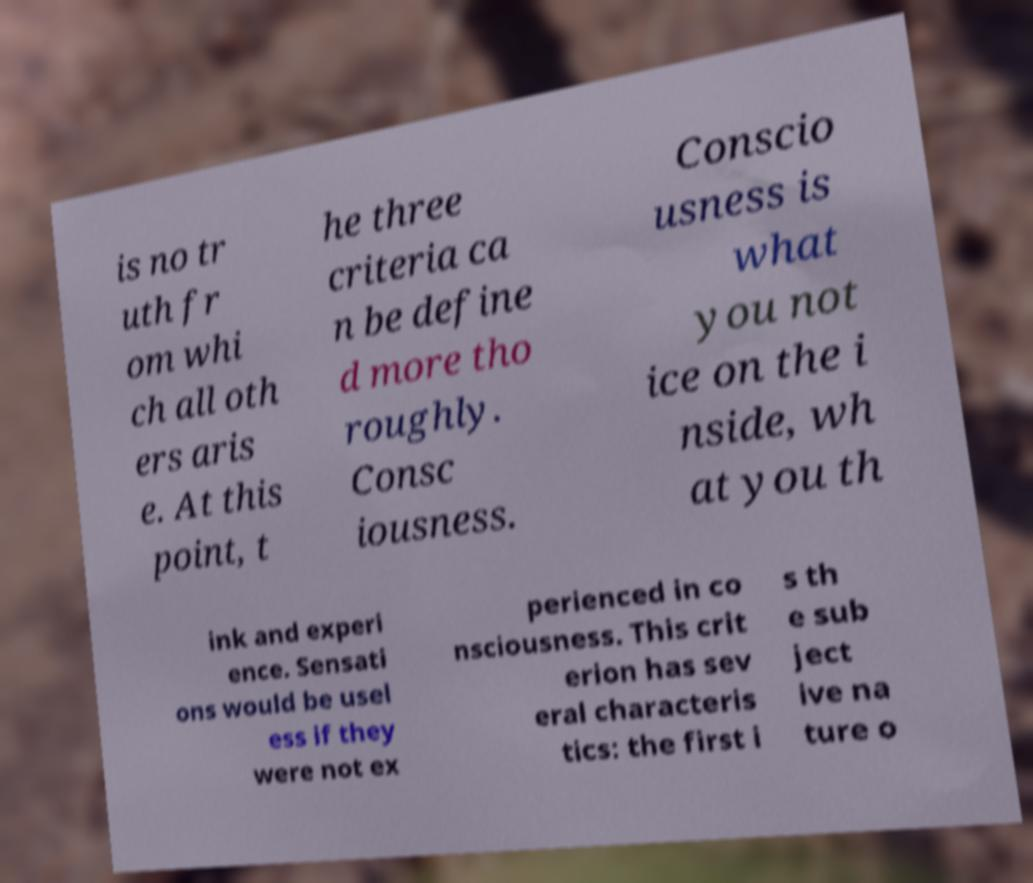There's text embedded in this image that I need extracted. Can you transcribe it verbatim? is no tr uth fr om whi ch all oth ers aris e. At this point, t he three criteria ca n be define d more tho roughly. Consc iousness. Conscio usness is what you not ice on the i nside, wh at you th ink and experi ence. Sensati ons would be usel ess if they were not ex perienced in co nsciousness. This crit erion has sev eral characteris tics: the first i s th e sub ject ive na ture o 